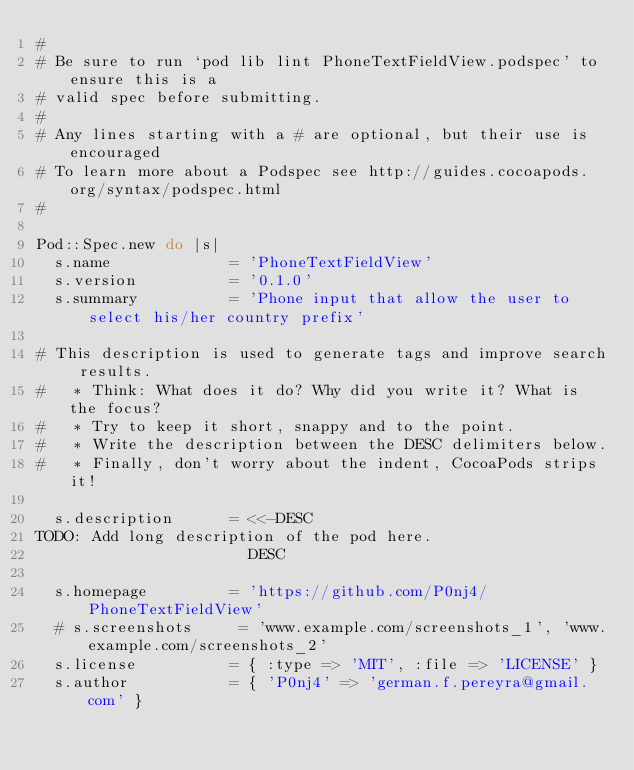Convert code to text. <code><loc_0><loc_0><loc_500><loc_500><_Ruby_>#
# Be sure to run `pod lib lint PhoneTextFieldView.podspec' to ensure this is a
# valid spec before submitting.
#
# Any lines starting with a # are optional, but their use is encouraged
# To learn more about a Podspec see http://guides.cocoapods.org/syntax/podspec.html
#

Pod::Spec.new do |s|
  s.name             = 'PhoneTextFieldView'
  s.version          = '0.1.0'
  s.summary          = 'Phone input that allow the user to select his/her country prefix'

# This description is used to generate tags and improve search results.
#   * Think: What does it do? Why did you write it? What is the focus?
#   * Try to keep it short, snappy and to the point.
#   * Write the description between the DESC delimiters below.
#   * Finally, don't worry about the indent, CocoaPods strips it!

  s.description      = <<-DESC
TODO: Add long description of the pod here.
                       DESC

  s.homepage         = 'https://github.com/P0nj4/PhoneTextFieldView'
  # s.screenshots     = 'www.example.com/screenshots_1', 'www.example.com/screenshots_2'
  s.license          = { :type => 'MIT', :file => 'LICENSE' }
  s.author           = { 'P0nj4' => 'german.f.pereyra@gmail.com' }</code> 